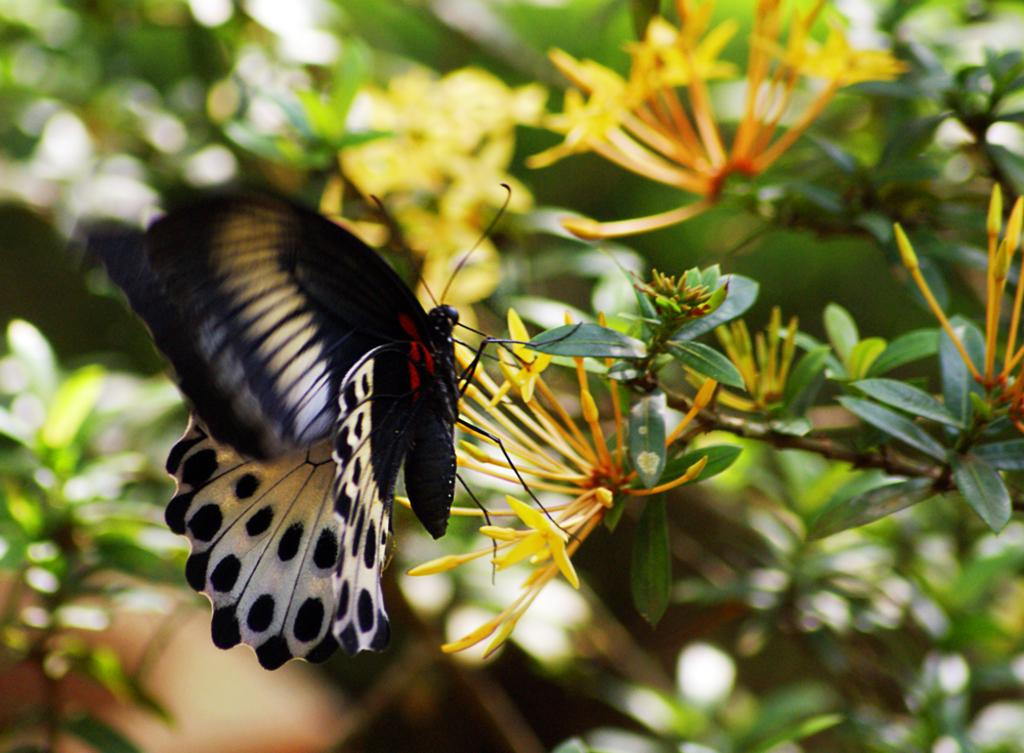What is the main subject of the image? There is a butterfly in the image. Where is the butterfly located in the image? The butterfly is on the flowers of a plant. What type of sign can be seen in the image? There is no sign present in the image; it features a butterfly on the flowers of a plant. How many men are visible in the image? There are no men present in the image. 